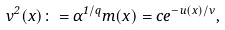<formula> <loc_0><loc_0><loc_500><loc_500>v ^ { 2 } ( x ) \colon = \alpha ^ { 1 / q } m ( x ) = c e ^ { - u ( x ) / \nu } ,</formula> 